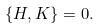Convert formula to latex. <formula><loc_0><loc_0><loc_500><loc_500>\{ H , K \} = 0 .</formula> 